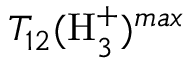Convert formula to latex. <formula><loc_0><loc_0><loc_500><loc_500>T _ { 1 2 } ( H _ { 3 } ^ { + } ) ^ { \max }</formula> 